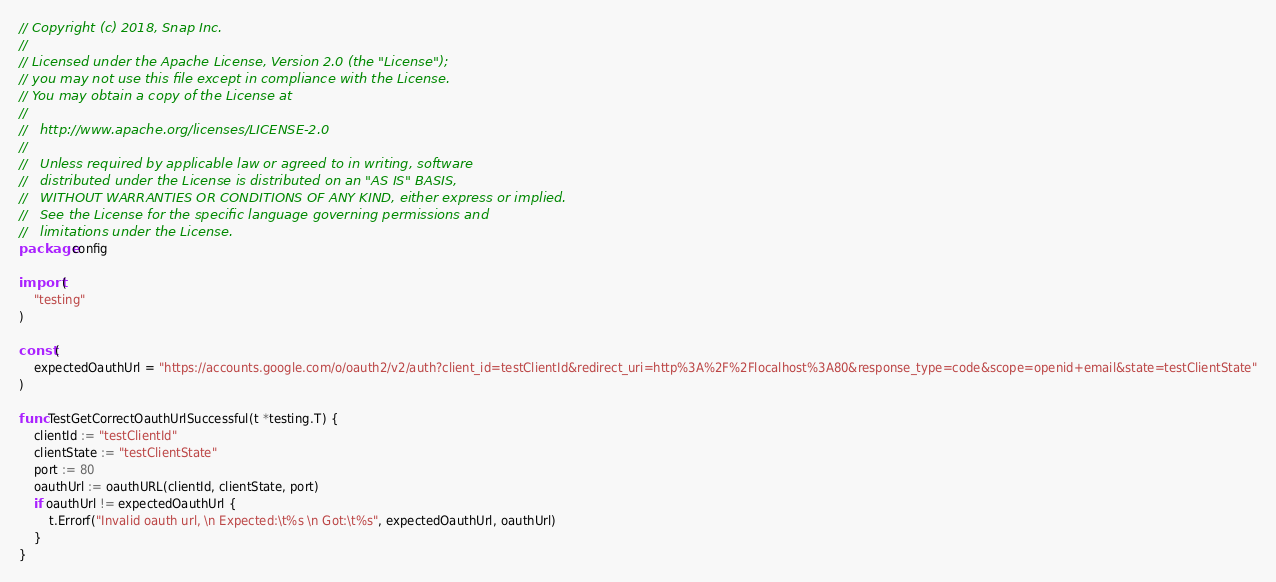<code> <loc_0><loc_0><loc_500><loc_500><_Go_>// Copyright (c) 2018, Snap Inc.
//
// Licensed under the Apache License, Version 2.0 (the "License");
// you may not use this file except in compliance with the License.
// You may obtain a copy of the License at
//
//   http://www.apache.org/licenses/LICENSE-2.0
//
//   Unless required by applicable law or agreed to in writing, software
//   distributed under the License is distributed on an "AS IS" BASIS,
//   WITHOUT WARRANTIES OR CONDITIONS OF ANY KIND, either express or implied.
//   See the License for the specific language governing permissions and
//   limitations under the License.
package config

import (
	"testing"
)

const (
	expectedOauthUrl = "https://accounts.google.com/o/oauth2/v2/auth?client_id=testClientId&redirect_uri=http%3A%2F%2Flocalhost%3A80&response_type=code&scope=openid+email&state=testClientState"
)

func TestGetCorrectOauthUrlSuccessful(t *testing.T) {
	clientId := "testClientId"
	clientState := "testClientState"
	port := 80
	oauthUrl := oauthURL(clientId, clientState, port)
	if oauthUrl != expectedOauthUrl {
		t.Errorf("Invalid oauth url, \n Expected:\t%s \n Got:\t%s", expectedOauthUrl, oauthUrl)
	}
}
</code> 